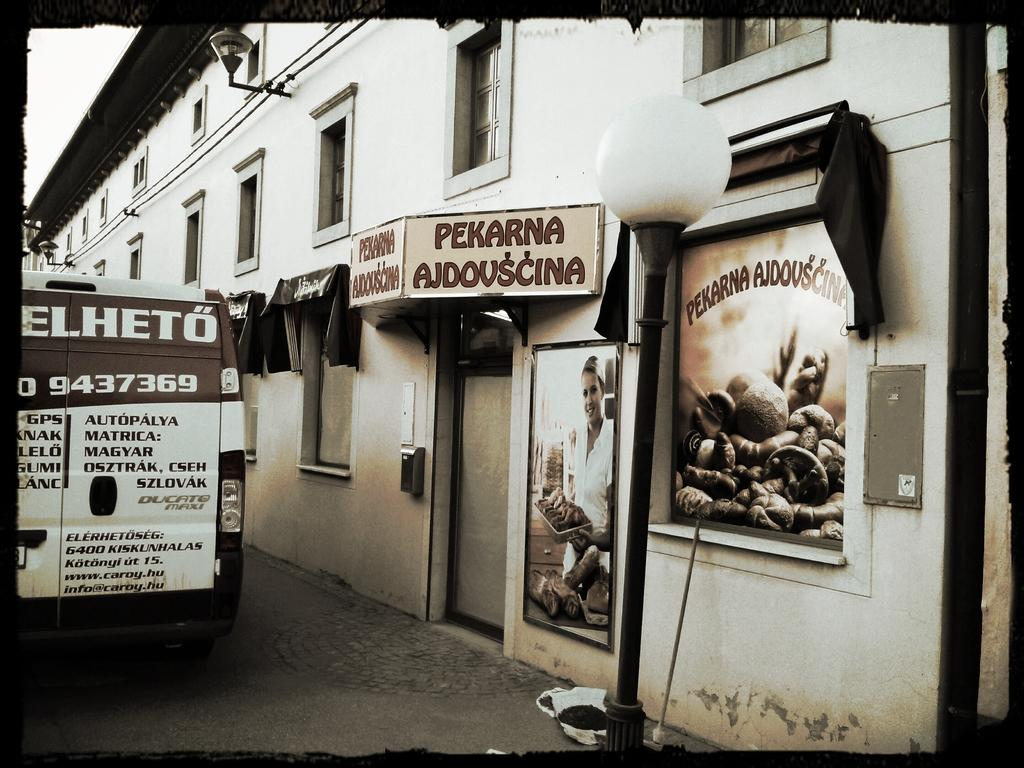<image>
Relay a brief, clear account of the picture shown. van that has number 9437369 on back parked in front of pekarna ajdovscina 